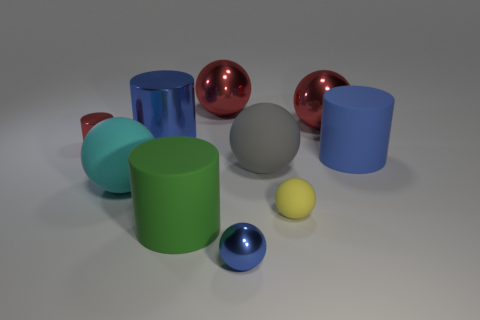Subtract all green cylinders. How many cylinders are left? 3 Subtract all cylinders. How many objects are left? 6 Subtract 2 cylinders. How many cylinders are left? 2 Subtract all red cylinders. How many cylinders are left? 3 Subtract all cyan cylinders. How many yellow balls are left? 1 Subtract all large spheres. Subtract all yellow rubber objects. How many objects are left? 5 Add 2 big matte balls. How many big matte balls are left? 4 Add 2 small spheres. How many small spheres exist? 4 Subtract 0 purple balls. How many objects are left? 10 Subtract all red cylinders. Subtract all gray spheres. How many cylinders are left? 3 